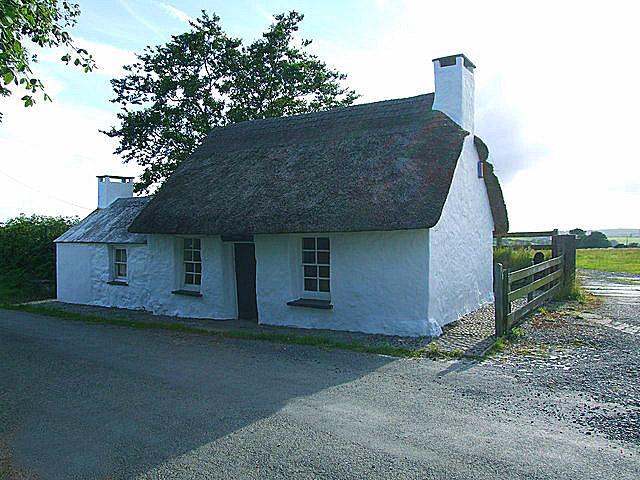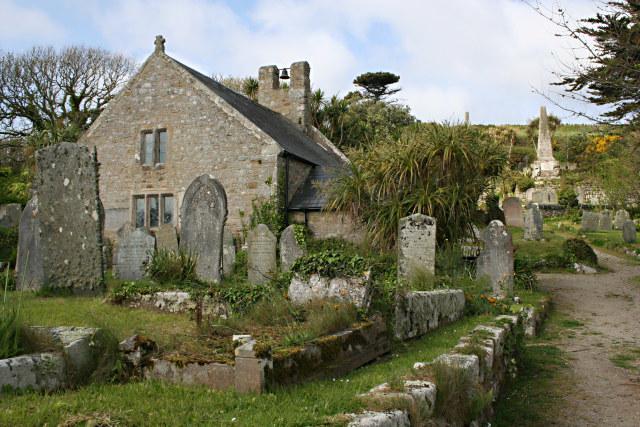The first image is the image on the left, the second image is the image on the right. Evaluate the accuracy of this statement regarding the images: "One image shows buildings with smooth, flat, straight roofs, and the the other image shows rustic-looking stone buildings with roofs that are textured and uneven-looking.". Is it true? Answer yes or no. No. 